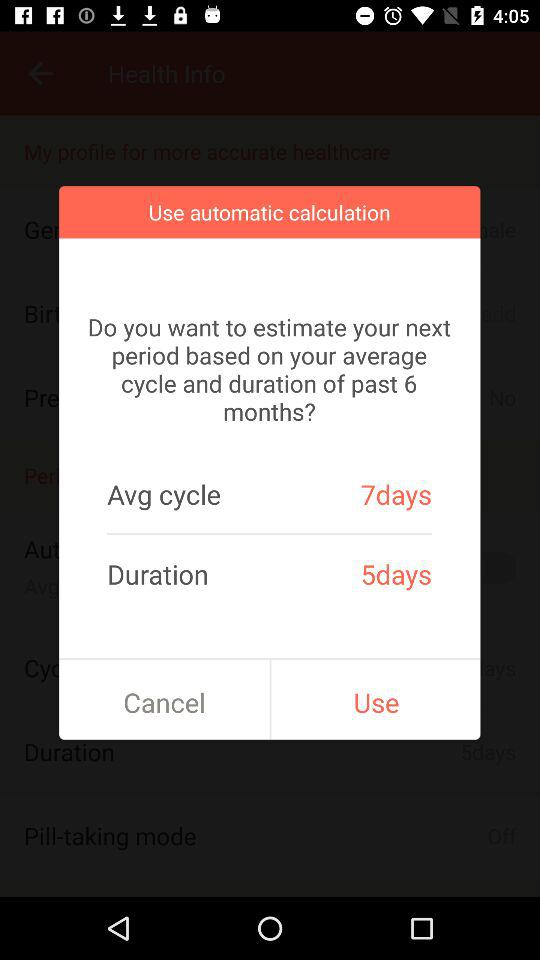How long is the cycle on average? On average, the cycle is 7 days long. 